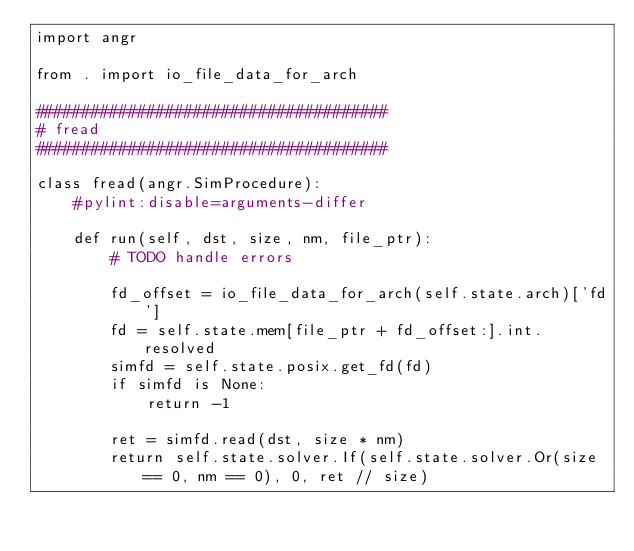<code> <loc_0><loc_0><loc_500><loc_500><_Python_>import angr

from . import io_file_data_for_arch

######################################
# fread
######################################

class fread(angr.SimProcedure):
    #pylint:disable=arguments-differ

    def run(self, dst, size, nm, file_ptr):
        # TODO handle errors

        fd_offset = io_file_data_for_arch(self.state.arch)['fd']
        fd = self.state.mem[file_ptr + fd_offset:].int.resolved
        simfd = self.state.posix.get_fd(fd)
        if simfd is None:
            return -1

        ret = simfd.read(dst, size * nm)
        return self.state.solver.If(self.state.solver.Or(size == 0, nm == 0), 0, ret // size)
</code> 